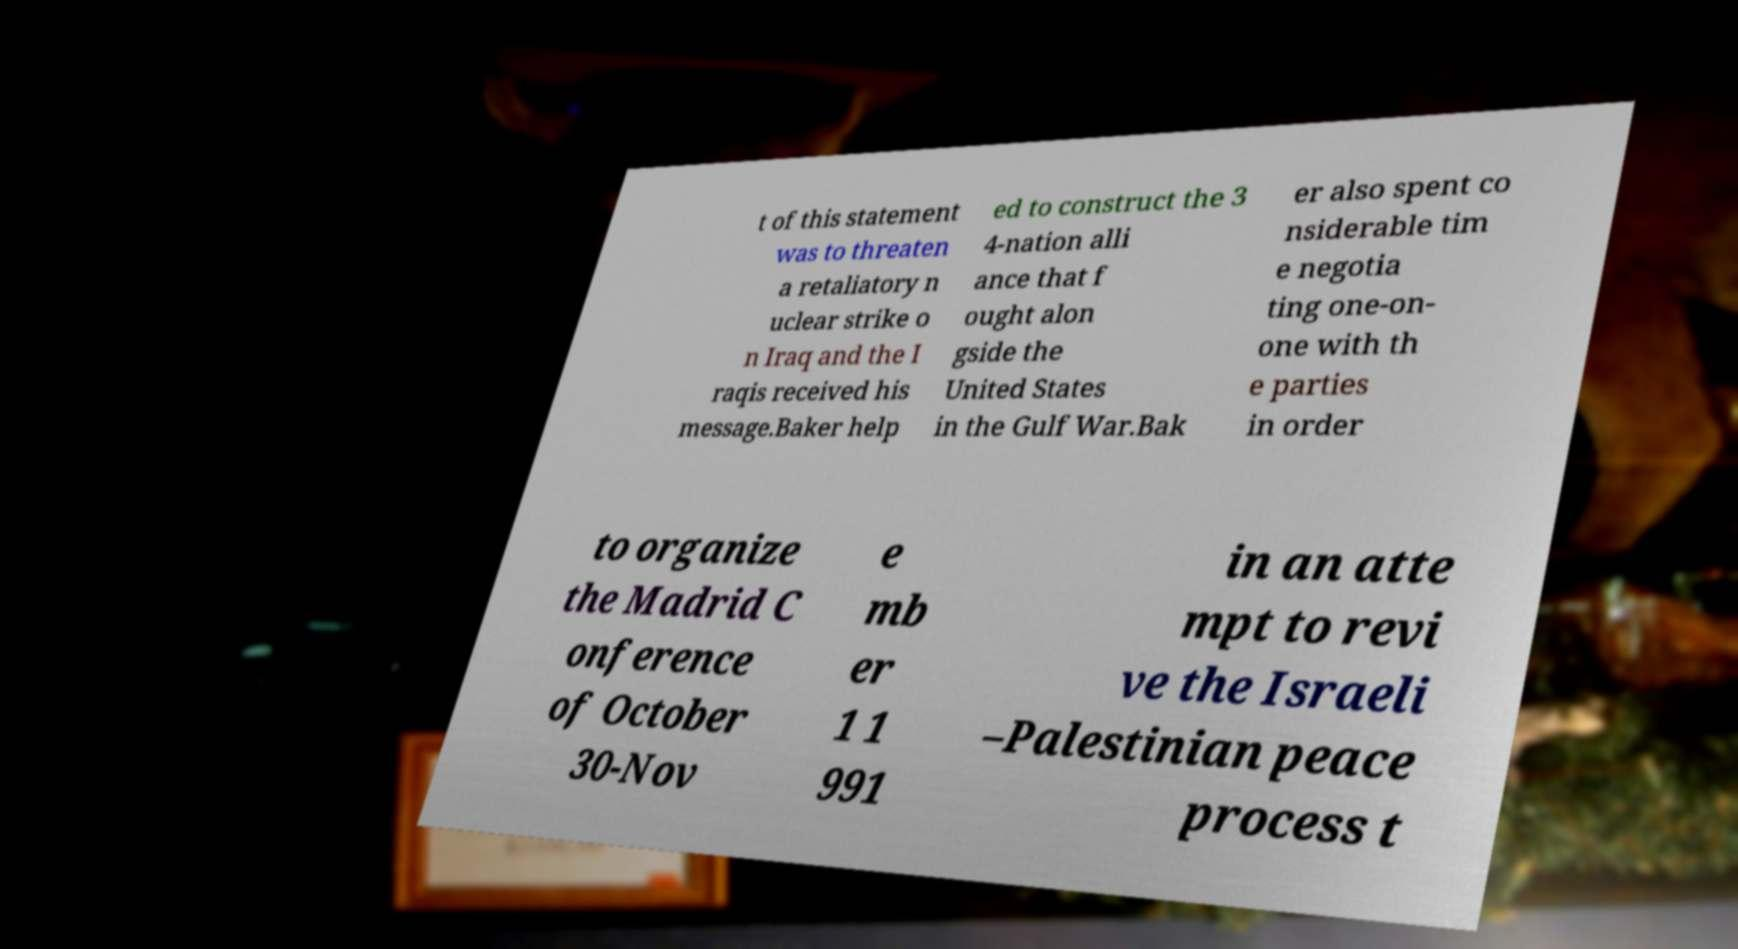Can you accurately transcribe the text from the provided image for me? t of this statement was to threaten a retaliatory n uclear strike o n Iraq and the I raqis received his message.Baker help ed to construct the 3 4-nation alli ance that f ought alon gside the United States in the Gulf War.Bak er also spent co nsiderable tim e negotia ting one-on- one with th e parties in order to organize the Madrid C onference of October 30-Nov e mb er 1 1 991 in an atte mpt to revi ve the Israeli –Palestinian peace process t 